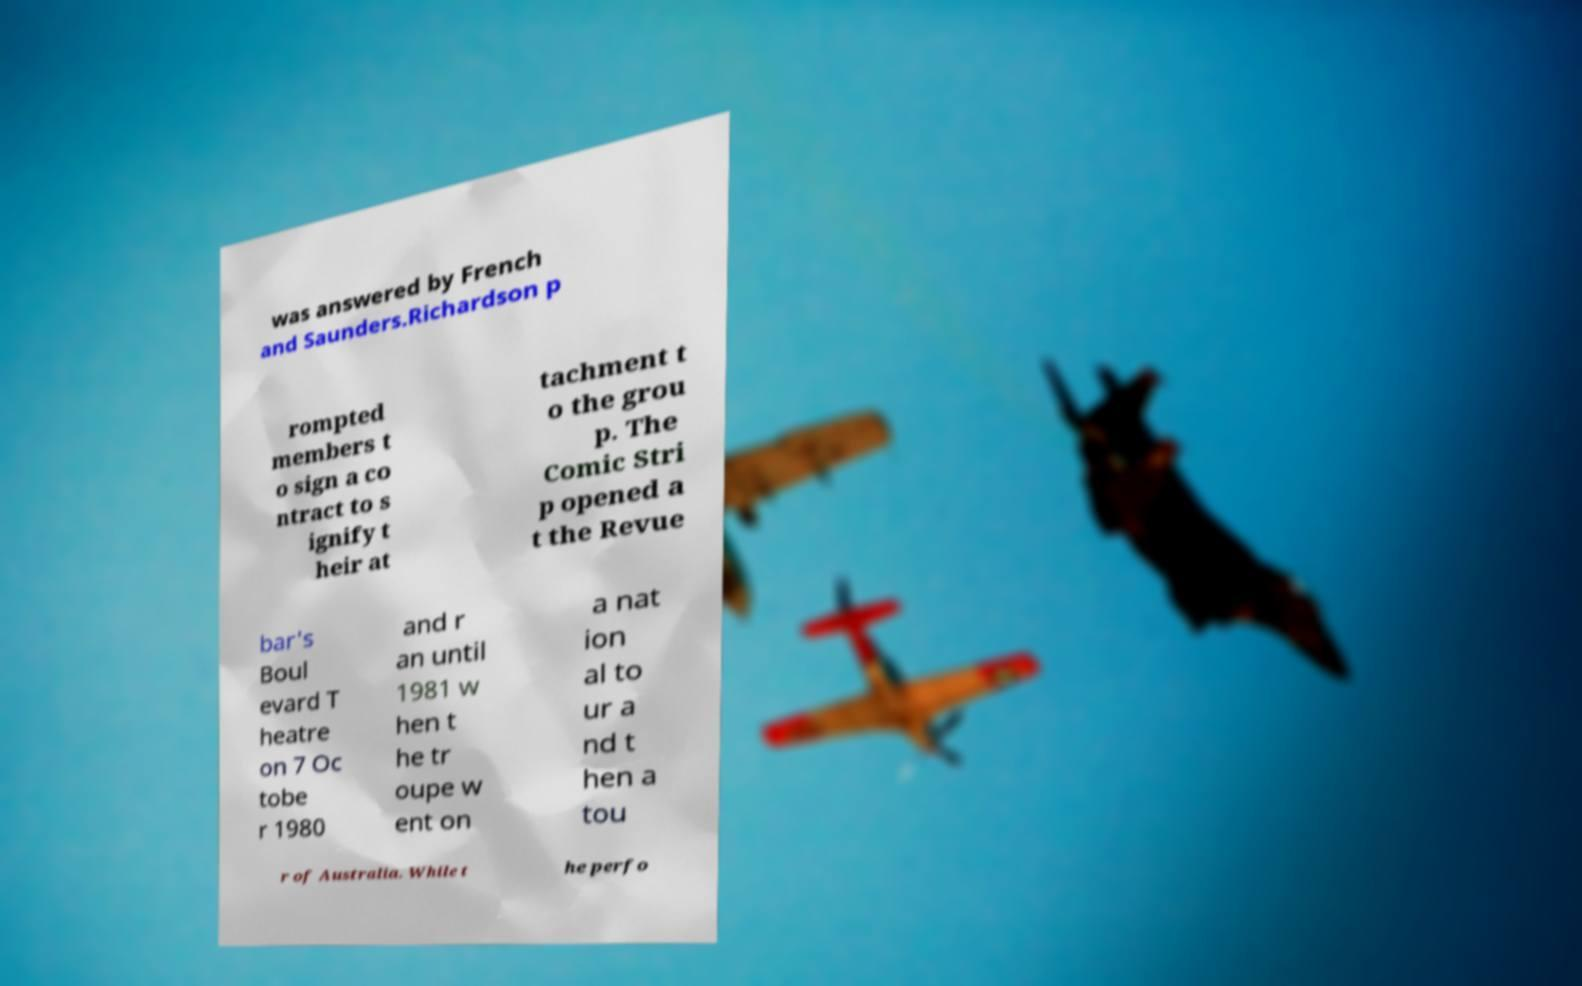Please identify and transcribe the text found in this image. was answered by French and Saunders.Richardson p rompted members t o sign a co ntract to s ignify t heir at tachment t o the grou p. The Comic Stri p opened a t the Revue bar's Boul evard T heatre on 7 Oc tobe r 1980 and r an until 1981 w hen t he tr oupe w ent on a nat ion al to ur a nd t hen a tou r of Australia. While t he perfo 